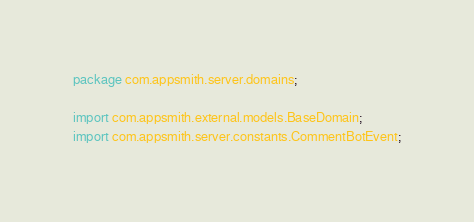<code> <loc_0><loc_0><loc_500><loc_500><_Java_>package com.appsmith.server.domains;

import com.appsmith.external.models.BaseDomain;
import com.appsmith.server.constants.CommentBotEvent;</code> 